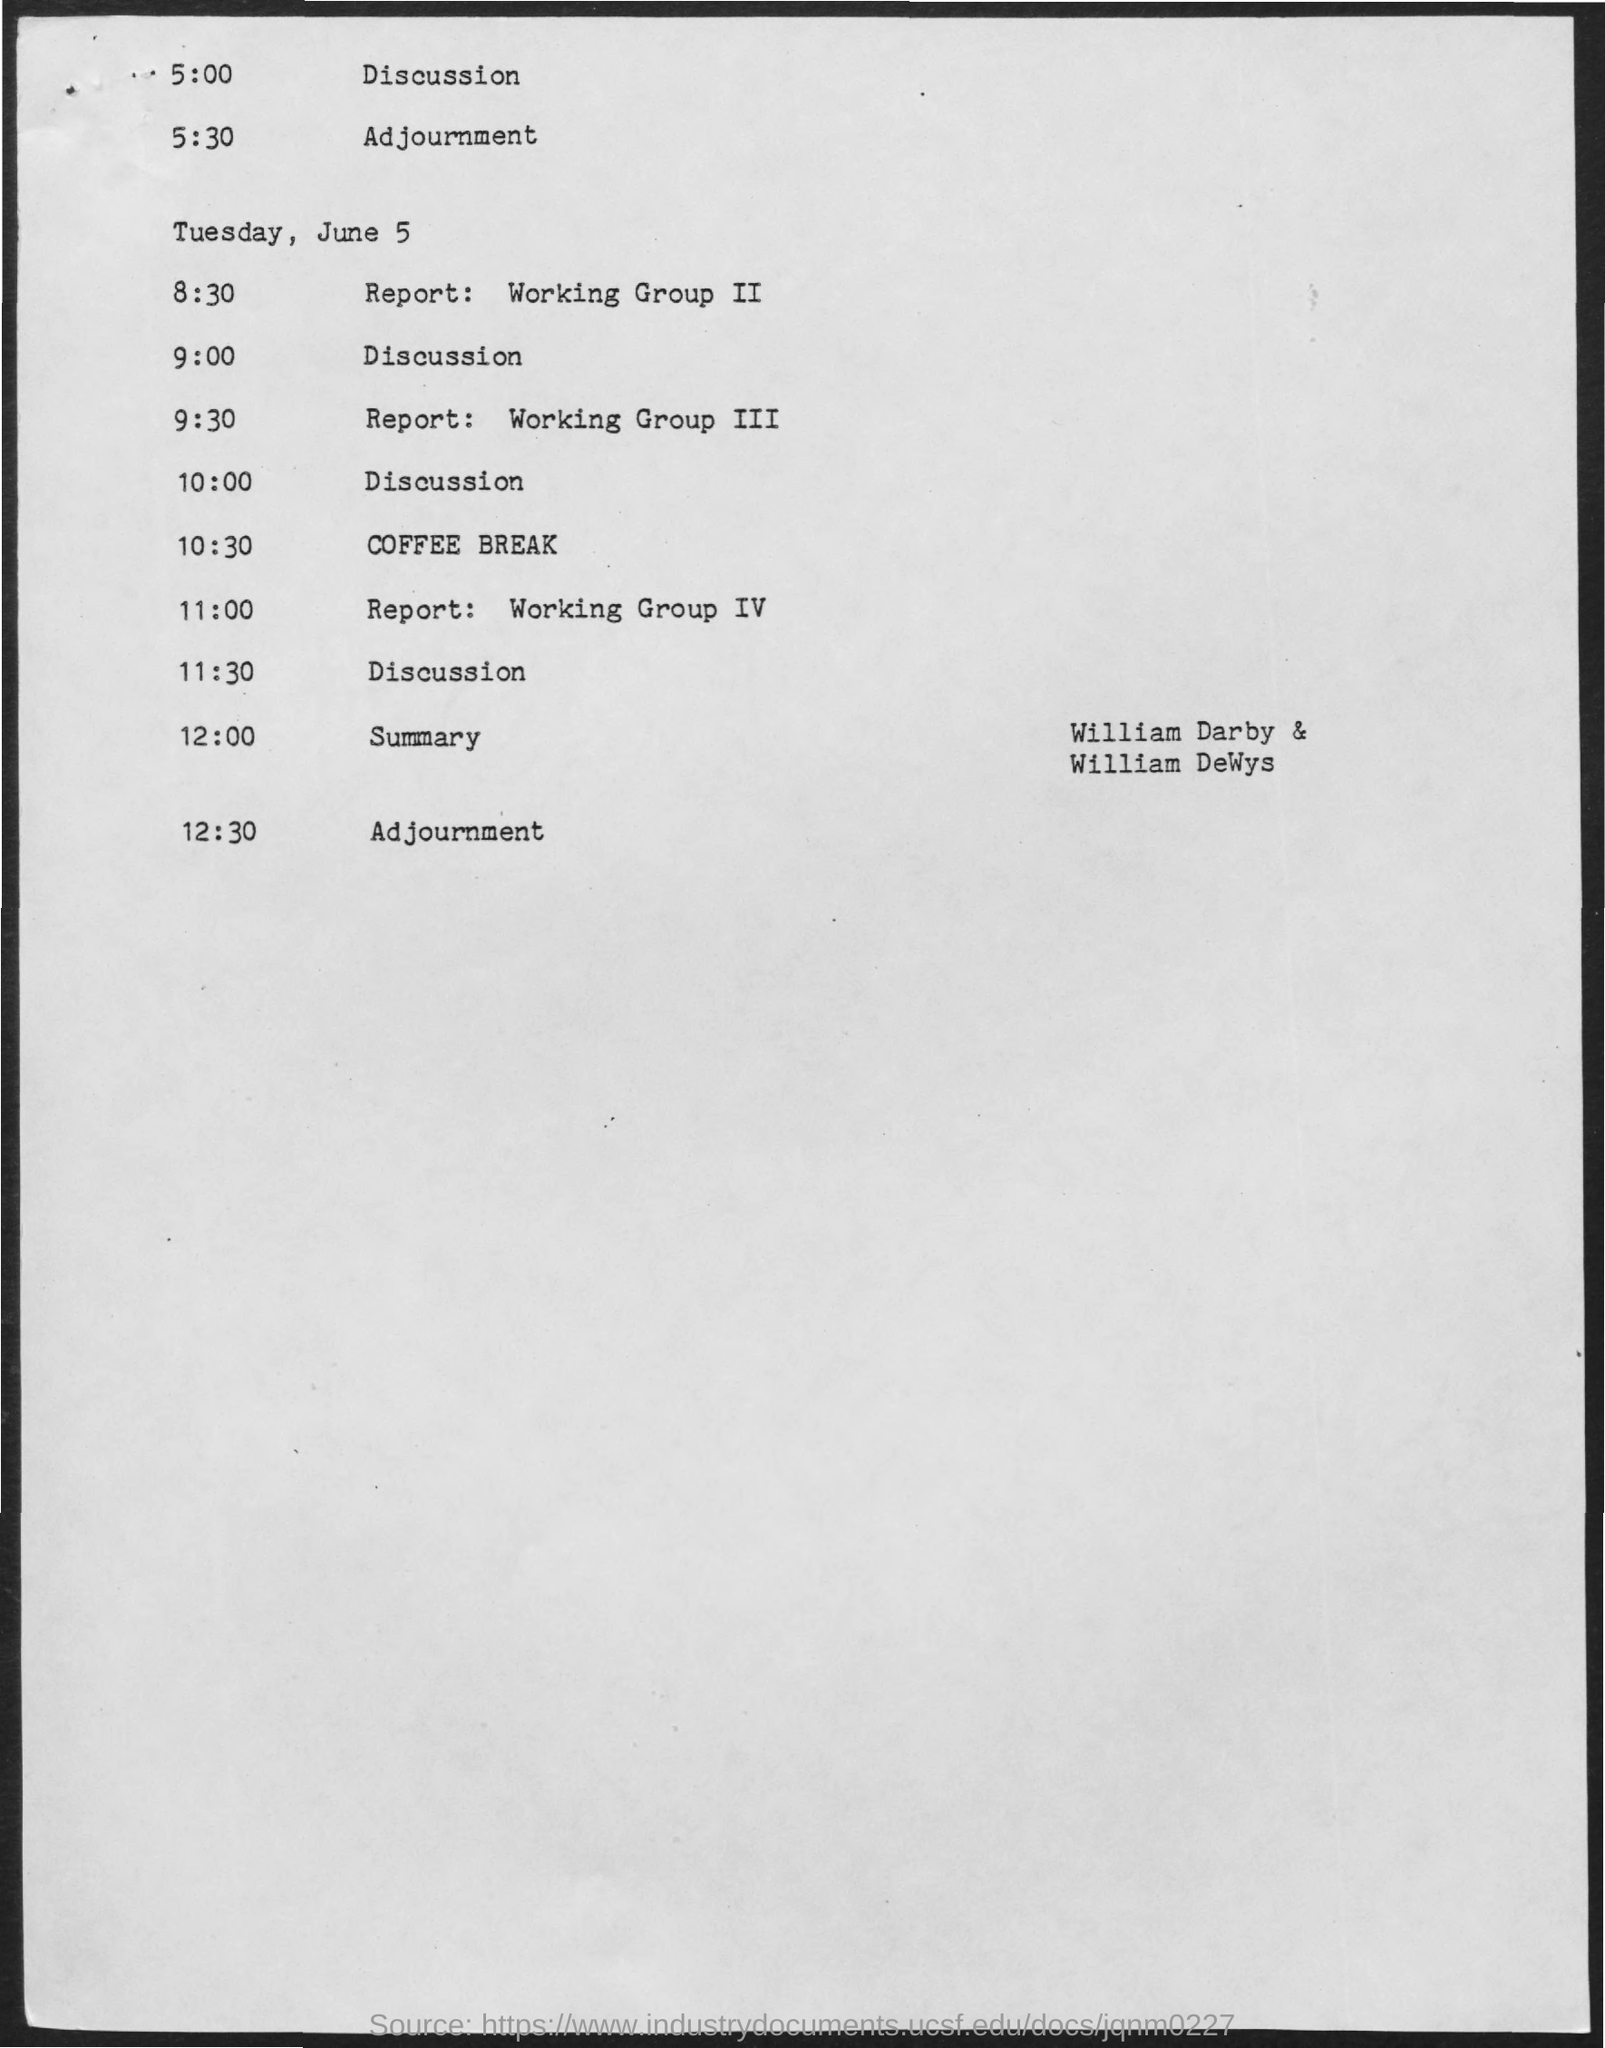Highlight a few significant elements in this photo. The coffee break is scheduled for 10:30. 